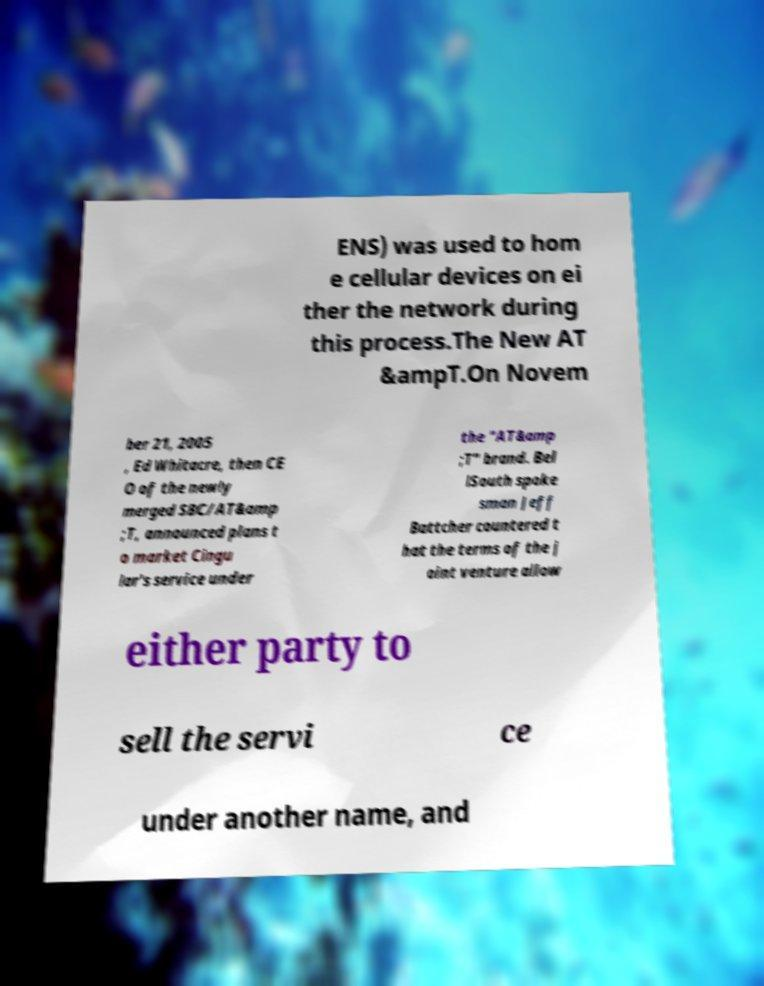I need the written content from this picture converted into text. Can you do that? ENS) was used to hom e cellular devices on ei ther the network during this process.The New AT &ampT.On Novem ber 21, 2005 , Ed Whitacre, then CE O of the newly merged SBC/AT&amp ;T, announced plans t o market Cingu lar's service under the "AT&amp ;T" brand. Bel lSouth spoke sman Jeff Battcher countered t hat the terms of the j oint venture allow either party to sell the servi ce under another name, and 